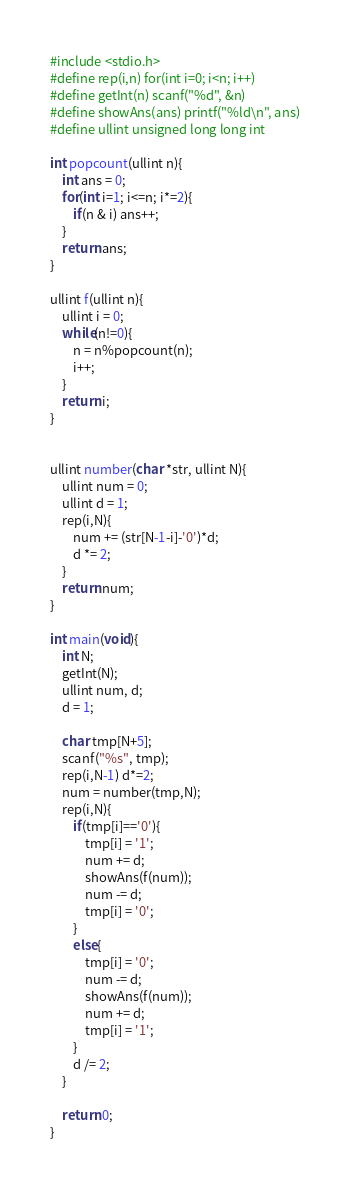Convert code to text. <code><loc_0><loc_0><loc_500><loc_500><_C_>#include <stdio.h>
#define rep(i,n) for(int i=0; i<n; i++)
#define getInt(n) scanf("%d", &n)
#define showAns(ans) printf("%ld\n", ans)
#define ullint unsigned long long int

int popcount(ullint n){
    int ans = 0;
    for(int i=1; i<=n; i*=2){
        if(n & i) ans++;
    }
    return ans;
}

ullint f(ullint n){
    ullint i = 0;
    while(n!=0){
        n = n%popcount(n);
        i++;
    }
    return i;
}


ullint number(char *str, ullint N){
    ullint num = 0;
    ullint d = 1;
    rep(i,N){
        num += (str[N-1-i]-'0')*d;
        d *= 2;
    }
    return num;
}

int main(void){
    int N;
    getInt(N);
    ullint num, d;
    d = 1;

    char tmp[N+5];
    scanf("%s", tmp);
    rep(i,N-1) d*=2;
    num = number(tmp,N);
    rep(i,N){
        if(tmp[i]=='0'){
            tmp[i] = '1';
            num += d;
            showAns(f(num));
            num -= d;
            tmp[i] = '0';
        }
        else{
            tmp[i] = '0';
            num -= d;
            showAns(f(num));
            num += d;
            tmp[i] = '1';
        }
        d /= 2;
    }

    return 0;
}
</code> 